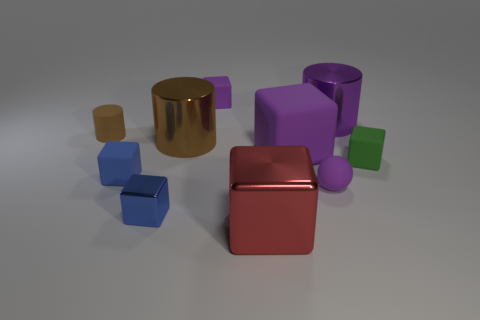How many other things are there of the same material as the purple ball?
Make the answer very short. 5. Is there a green metallic block of the same size as the red cube?
Offer a terse response. No. There is a big shiny thing in front of the tiny green thing; how many tiny brown rubber cylinders are behind it?
Ensure brevity in your answer.  1. What is the tiny ball made of?
Offer a very short reply. Rubber. What number of objects are on the right side of the large red block?
Your response must be concise. 4. Is the color of the small ball the same as the tiny metallic block?
Your response must be concise. No. How many other cubes have the same color as the big matte cube?
Your answer should be compact. 1. Is the number of tiny red rubber blocks greater than the number of large red cubes?
Offer a very short reply. No. How big is the metallic thing that is both to the right of the brown metal thing and to the left of the large purple block?
Keep it short and to the point. Large. Do the brown object that is right of the brown matte cylinder and the purple object left of the large red cube have the same material?
Offer a terse response. No. 